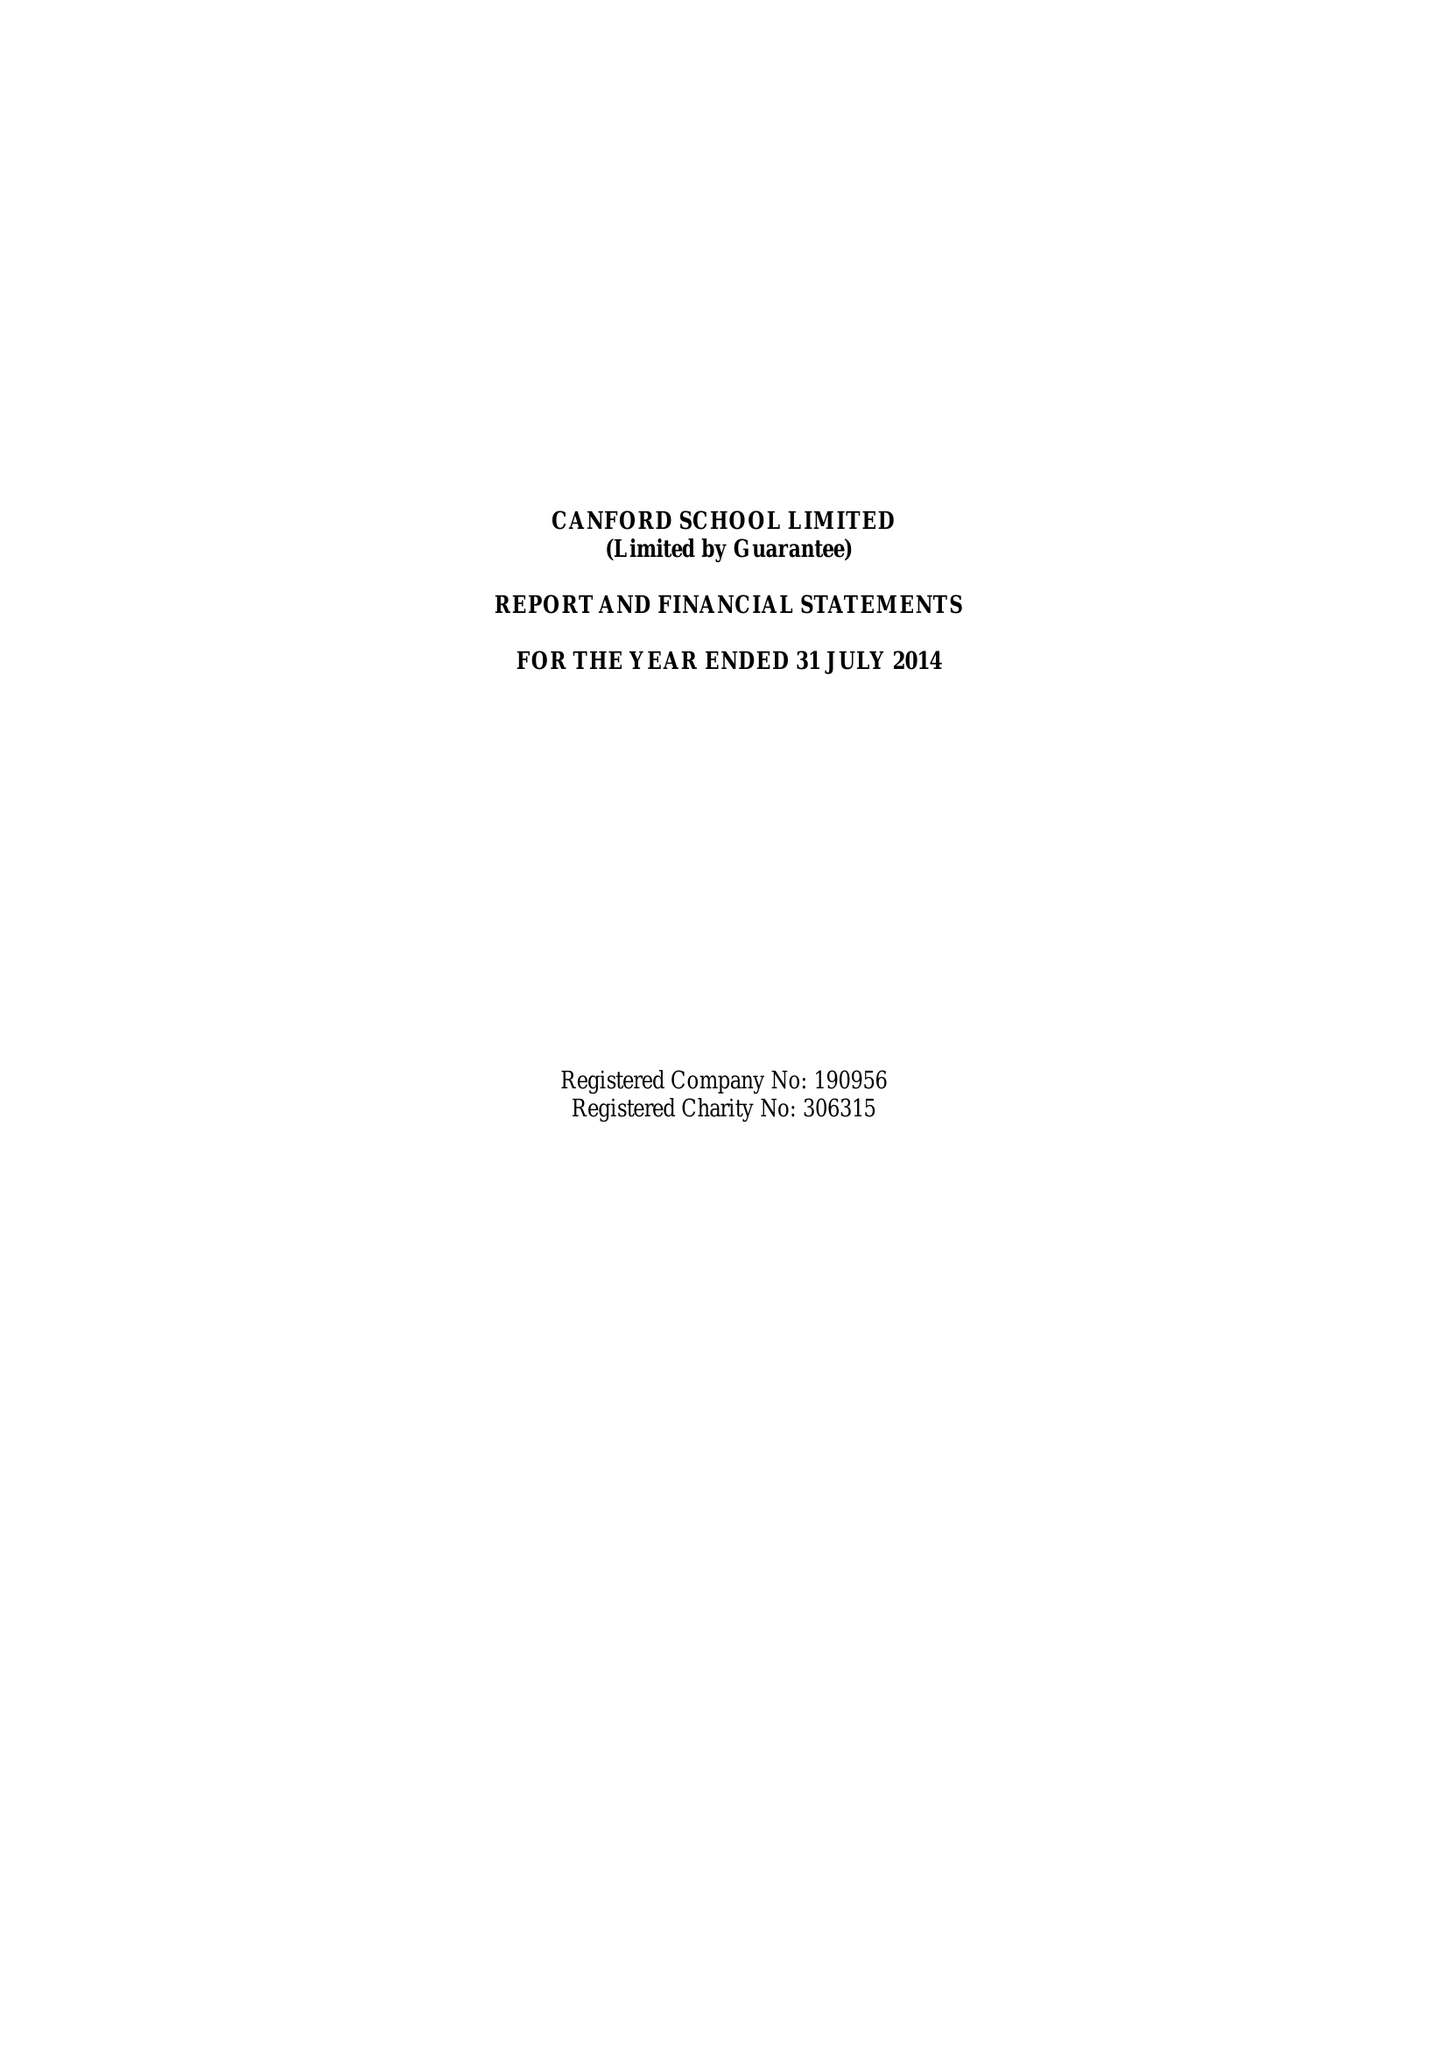What is the value for the spending_annually_in_british_pounds?
Answer the question using a single word or phrase. 17761637.00 